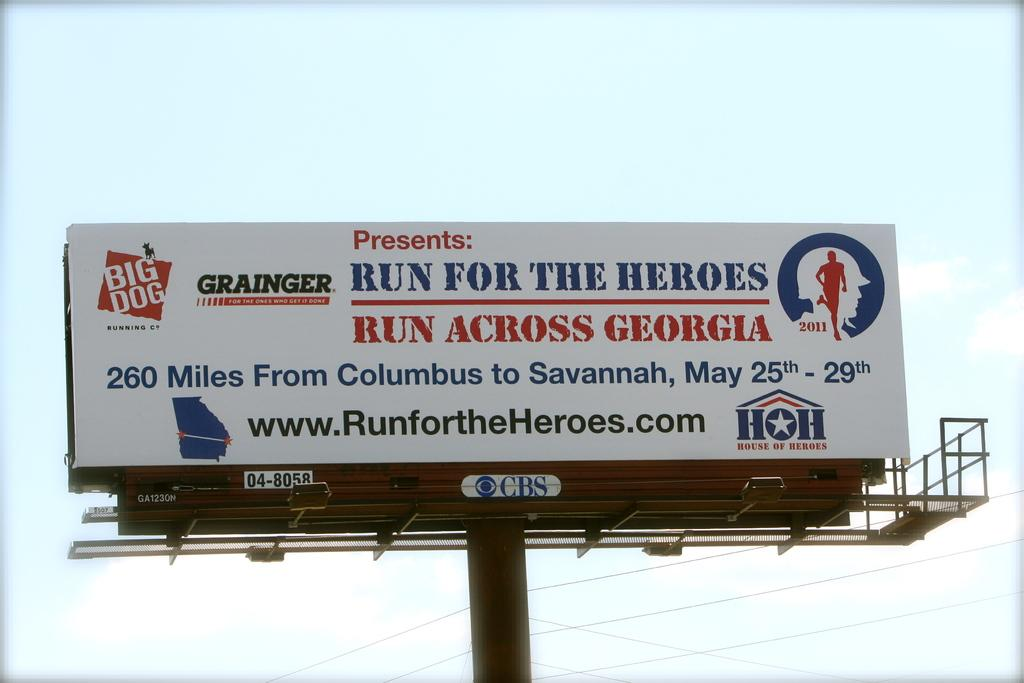<image>
Give a short and clear explanation of the subsequent image. A billboard on a huge pole with Run For The Heroes written in blue. 